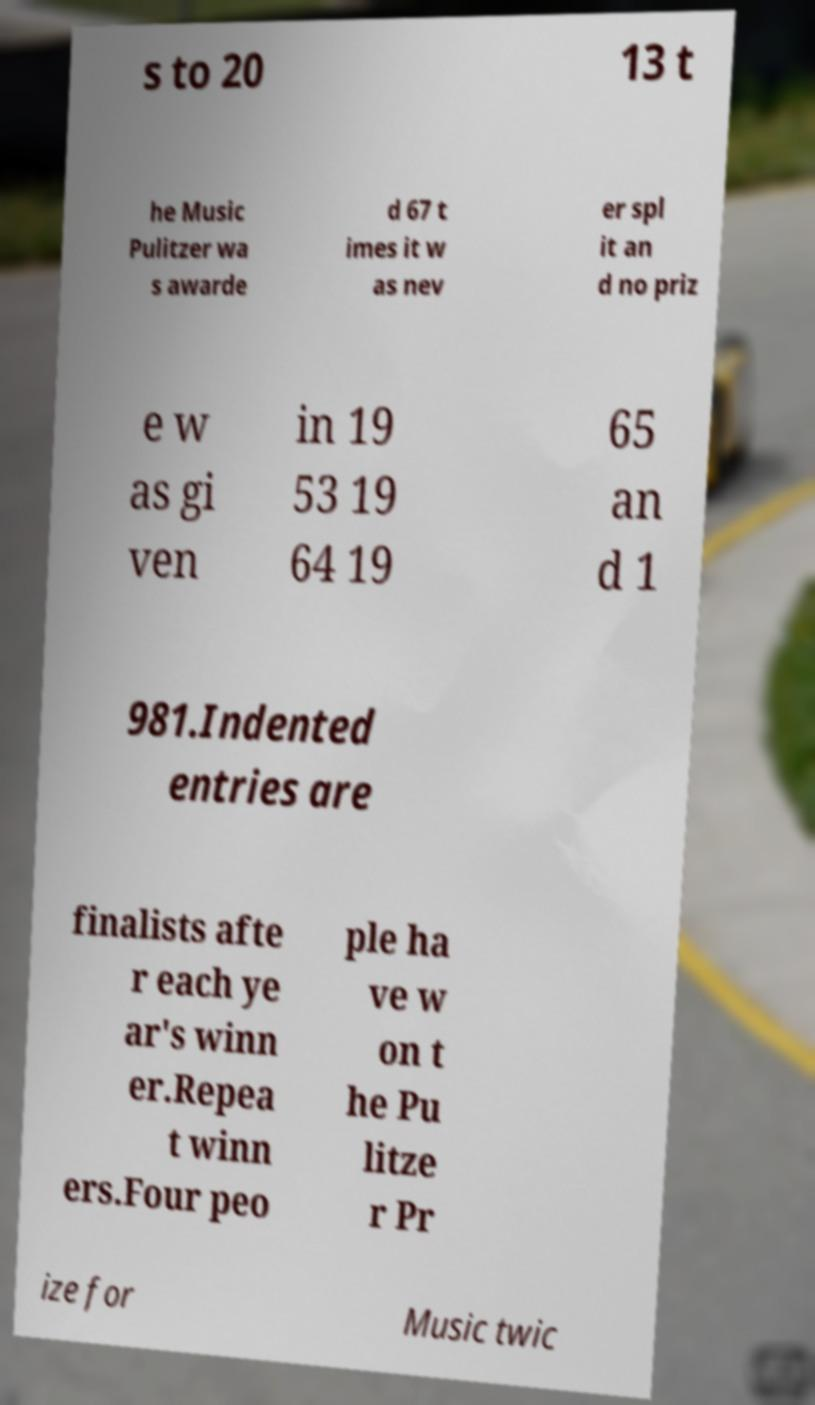Could you assist in decoding the text presented in this image and type it out clearly? s to 20 13 t he Music Pulitzer wa s awarde d 67 t imes it w as nev er spl it an d no priz e w as gi ven in 19 53 19 64 19 65 an d 1 981.Indented entries are finalists afte r each ye ar's winn er.Repea t winn ers.Four peo ple ha ve w on t he Pu litze r Pr ize for Music twic 